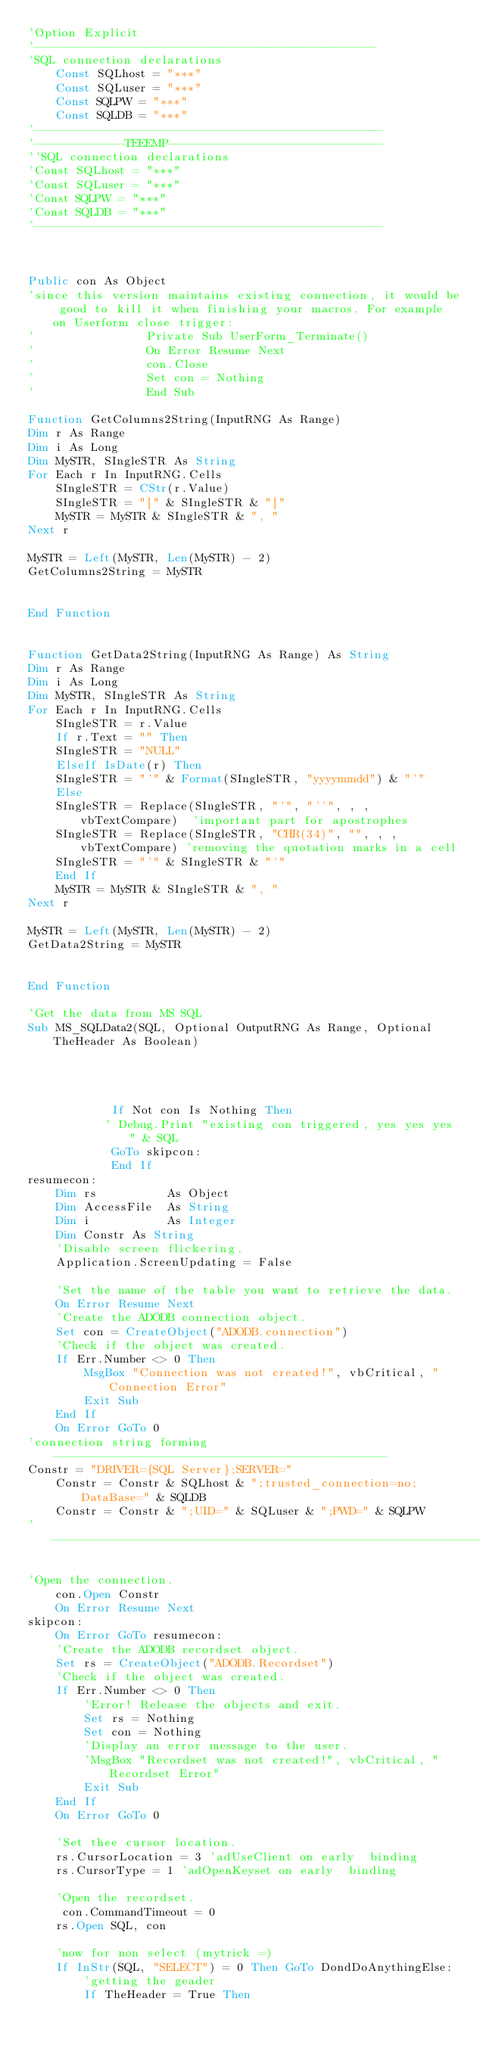Convert code to text. <code><loc_0><loc_0><loc_500><loc_500><_VisualBasic_>'Option Explicit
'-------------------------------------------------
'SQL connection declarations
    Const SQLhost = "***"
    Const SQLuser = "***"
    Const SQLPW = "***"
    Const SQLDB = "***"
'--------------------------------------------------
'-------------TEEEMP-------------------------------
''SQL connection declarations
'Const SQLhost = "***"
'Const SQLuser = "***"
'Const SQLPW = "***"
'Const SQLDB = "***"
'--------------------------------------------------



Public con As Object
'since this version maintains existing connection, it would be good to kill it when finishing your macros. For example on Userform close trigger:
'                Private Sub UserForm_Terminate()
'                On Error Resume Next
'                con.Close
'                Set con = Nothing
'                End Sub

Function GetColumns2String(InputRNG As Range)
Dim r As Range
Dim i As Long
Dim MySTR, SIngleSTR As String
For Each r In InputRNG.Cells
    SIngleSTR = CStr(r.Value)
    SIngleSTR = "[" & SIngleSTR & "]"
    MySTR = MySTR & SIngleSTR & ", "
Next r

MySTR = Left(MySTR, Len(MySTR) - 2)
GetColumns2String = MySTR


End Function


Function GetData2String(InputRNG As Range) As String
Dim r As Range
Dim i As Long
Dim MySTR, SIngleSTR As String
For Each r In InputRNG.Cells
    SIngleSTR = r.Value
    If r.Text = "" Then
    SIngleSTR = "NULL"
    ElseIf IsDate(r) Then
    SIngleSTR = "'" & Format(SIngleSTR, "yyyymmdd") & "'"
    Else
    SIngleSTR = Replace(SIngleSTR, "'", "''", , , vbTextCompare)  'important part for apostrophes
    SIngleSTR = Replace(SIngleSTR, "CHR(34)", "", , , vbTextCompare) 'removing the quotation marks in a cell
    SIngleSTR = "'" & SIngleSTR & "'"
    End If
    MySTR = MySTR & SIngleSTR & ", "
Next r

MySTR = Left(MySTR, Len(MySTR) - 2)
GetData2String = MySTR


End Function

'Get the data from MS SQL
Sub MS_SQLData2(SQL, Optional OutputRNG As Range, Optional TheHeader As Boolean)




            If Not con Is Nothing Then
           ' Debug.Print "existing con triggered, yes yes yes " & SQL
            GoTo skipcon:
            End If
resumecon:
    Dim rs          As Object
    Dim AccessFile  As String
    Dim i           As Integer
    Dim Constr As String
    'Disable screen flickering.
    Application.ScreenUpdating = False
    
    'Set the name of the table you want to retrieve the data.
    On Error Resume Next
    'Create the ADODB connection object.
    Set con = CreateObject("ADODB.connection")
    'Check if the object was created.
    If Err.Number <> 0 Then
        MsgBox "Connection was not created!", vbCritical, "Connection Error"
        Exit Sub
    End If
    On Error GoTo 0
'connection string forming------------------------------------------------
Constr = "DRIVER={SQL Server};SERVER="
    Constr = Constr & SQLhost & ";trusted_connection=no;DataBase=" & SQLDB
    Constr = Constr & ";UID=" & SQLuser & ";PWD=" & SQLPW
'-------------------------------------------------------------------------

'Open the connection.
    con.Open Constr
    On Error Resume Next
skipcon:
    On Error GoTo resumecon:
    'Create the ADODB recordset object.
    Set rs = CreateObject("ADODB.Recordset")
    'Check if the object was created.
    If Err.Number <> 0 Then
        'Error! Release the objects and exit.
        Set rs = Nothing
        Set con = Nothing
        'Display an error message to the user.
        'MsgBox "Recordset was not created!", vbCritical, "Recordset Error"
        Exit Sub
    End If
    On Error GoTo 0
         
    'Set thee cursor location.
    rs.CursorLocation = 3 'adUseClient on early  binding
    rs.CursorType = 1 'adOpenKeyset on early  binding
    
    'Open the recordset.
     con.CommandTimeout = 0
    rs.Open SQL, con
    
    'now for non select (mytrick =)
    If InStr(SQL, "SELECT") = 0 Then GoTo DondDoAnythingElse:
        'getting the geader
        If TheHeader = True Then</code> 